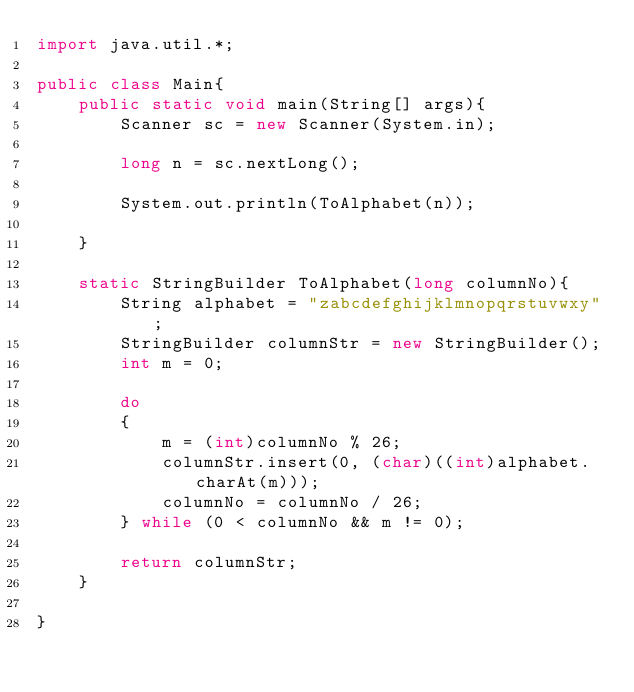<code> <loc_0><loc_0><loc_500><loc_500><_Java_>import java.util.*;

public class Main{
    public static void main(String[] args){
        Scanner sc = new Scanner(System.in);

        long n = sc.nextLong();

        System.out.println(ToAlphabet(n));

    }

    static StringBuilder ToAlphabet(long columnNo){
        String alphabet = "zabcdefghijklmnopqrstuvwxy";
        StringBuilder columnStr = new StringBuilder();
        int m = 0;

        do
        {
            m = (int)columnNo % 26;
            columnStr.insert(0, (char)((int)alphabet.charAt(m)));
            columnNo = columnNo / 26;
        } while (0 < columnNo && m != 0);

        return columnStr;
    }

}
</code> 